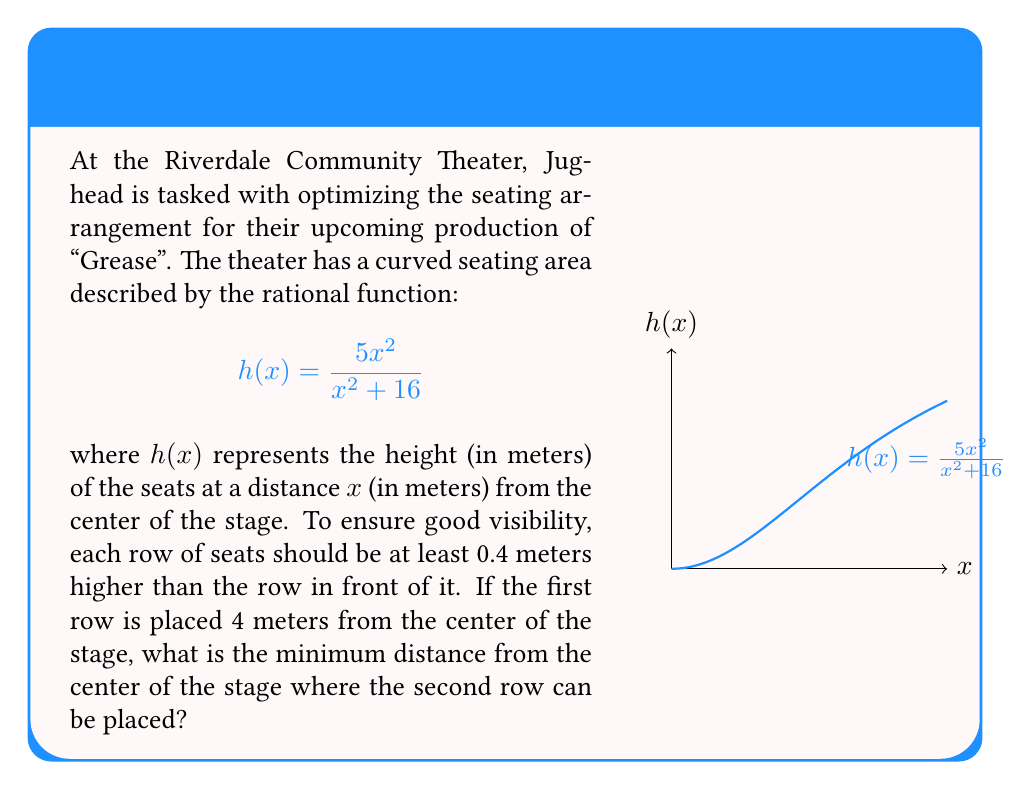Solve this math problem. Let's approach this step-by-step:

1) We know the first row is placed at $x_1 = 4$ meters from the center of the stage. Let's call the position of the second row $x_2$.

2) The height of the first row is:
   $$h(4) = \frac{5(4^2)}{4^2 + 16} = \frac{80}{32} = 2.5$$ meters

3) For the second row to be visible, it needs to be at least 0.4 meters higher than the first row. So the minimum height for the second row is:
   $$h(x_2) \geq 2.5 + 0.4 = 2.9$$ meters

4) We can set up an equation:
   $$\frac{5x_2^2}{x_2^2 + 16} = 2.9$$

5) Cross-multiply:
   $$5x_2^2 = 2.9(x_2^2 + 16)$$
   $$5x_2^2 = 2.9x_2^2 + 46.4$$

6) Subtract $2.9x_2^2$ from both sides:
   $$2.1x_2^2 = 46.4$$

7) Divide both sides by 2.1:
   $$x_2^2 = 22.0952$$

8) Take the square root of both sides:
   $$x_2 = \sqrt{22.0952} \approx 4.7$$

Therefore, the second row should be placed approximately 4.7 meters from the center of the stage.
Answer: 4.7 meters 